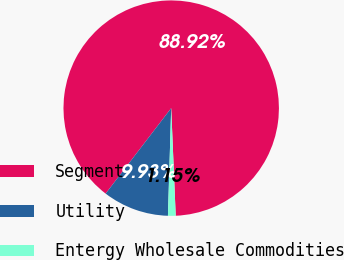<chart> <loc_0><loc_0><loc_500><loc_500><pie_chart><fcel>Segment<fcel>Utility<fcel>Entergy Wholesale Commodities<nl><fcel>88.92%<fcel>9.93%<fcel>1.15%<nl></chart> 